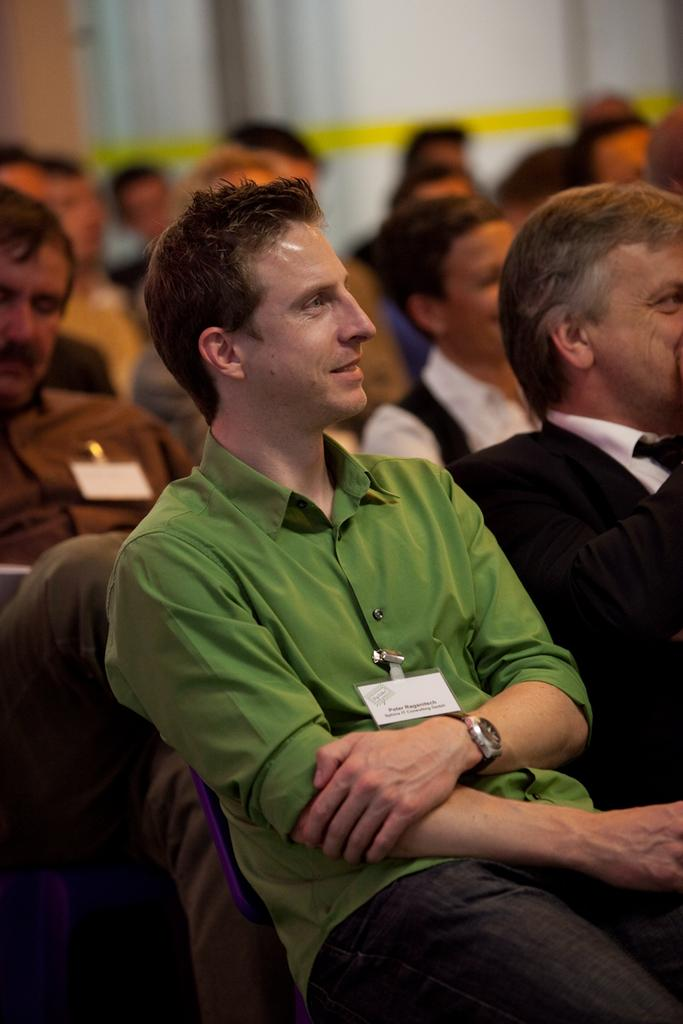What are the people in the image doing? The people in the image are sitting. Can you describe the background of the image? The background of the image is slightly blurry. What type of order is being followed by the people in the image? There is no indication of any order being followed in the image, as it only shows people sitting. 